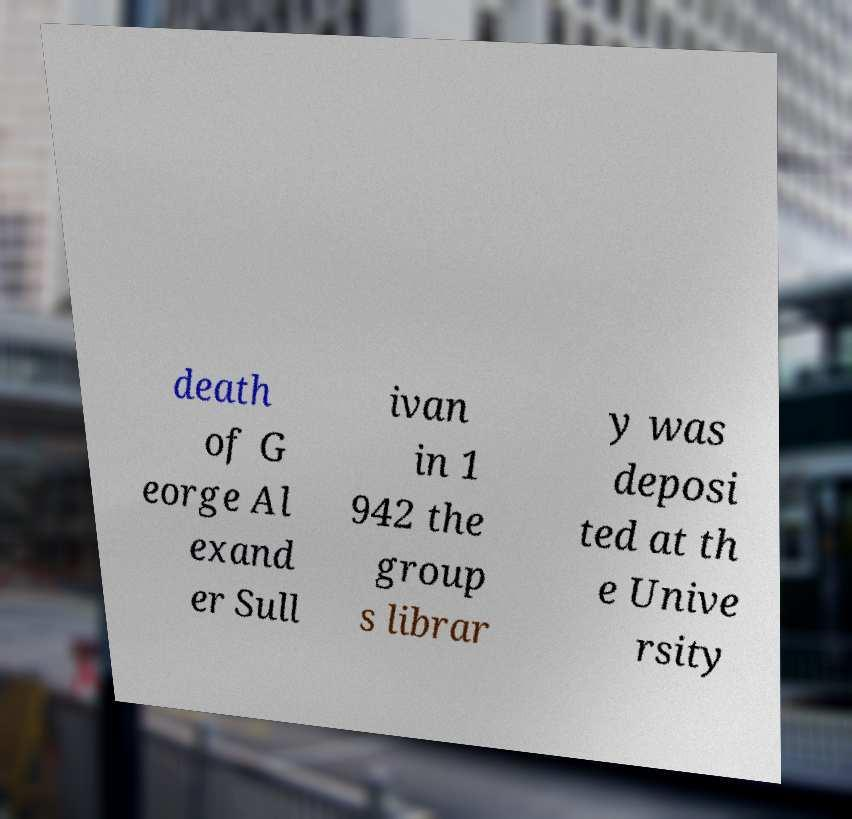Could you assist in decoding the text presented in this image and type it out clearly? death of G eorge Al exand er Sull ivan in 1 942 the group s librar y was deposi ted at th e Unive rsity 